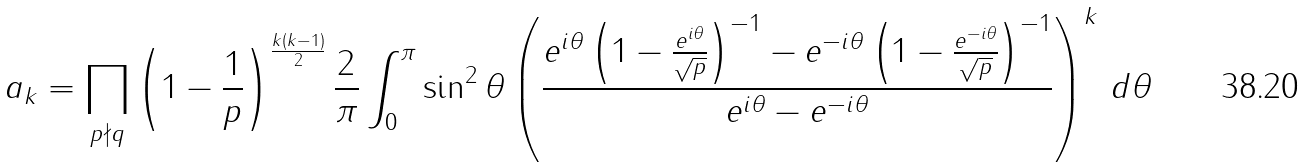Convert formula to latex. <formula><loc_0><loc_0><loc_500><loc_500>a _ { k } = \prod _ { p \nmid q } \left ( 1 - \frac { 1 } { p } \right ) ^ { \frac { k ( k - 1 ) } { 2 } } \frac { 2 } { \pi } \int _ { 0 } ^ { \pi } \sin ^ { 2 } \theta \left ( \frac { e ^ { i \theta } \left ( 1 - \frac { e ^ { i \theta } } { \sqrt { p } } \right ) ^ { - 1 } - e ^ { - i \theta } \left ( 1 - \frac { e ^ { - i \theta } } { \sqrt { p } } \right ) ^ { - 1 } } { e ^ { i \theta } - e ^ { - i \theta } } \right ) ^ { k } \, d \theta</formula> 